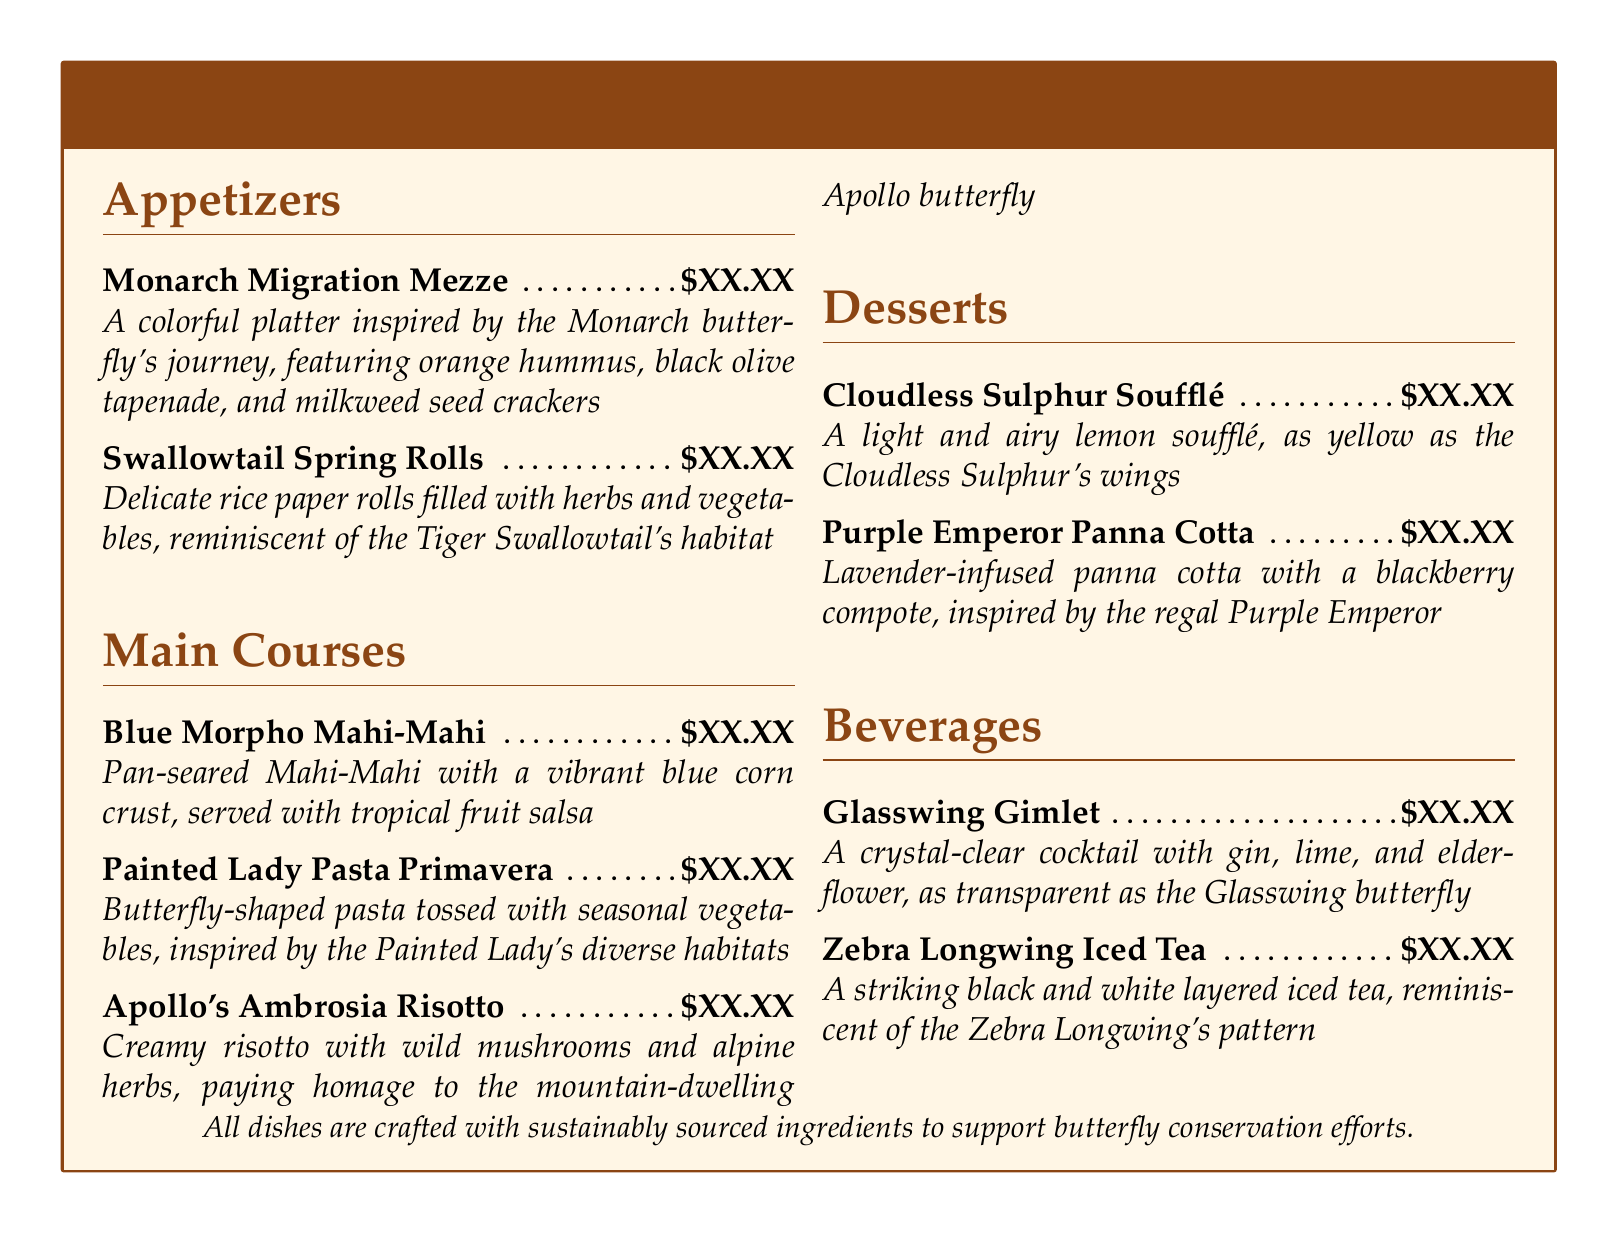What is the first appetizer listed? The first appetizer in the document is "Monarch Migration Mezze" as seen at the top of the appetizers section.
Answer: Monarch Migration Mezze How many main course options are there? The document lists three main course options under the Main Courses section.
Answer: 3 What is the key ingredient for the Cloudless Sulphur Soufflé? The Cloudless Sulphur Soufflé is described as a light and airy lemon soufflé, indicating that lemon is a key ingredient.
Answer: Lemon Which dessert is inspired by the Purple Emperor butterfly? The dessert inspired by the Purple Emperor butterfly is the "Purple Emperor Panna Cotta" as specified in the Desserts section.
Answer: Purple Emperor Panna Cotta What type of pasta is used in the Painted Lady Pasta Primavera? The Painted Lady Pasta Primavera features butterfly-shaped pasta, which is mentioned directly in the description.
Answer: Butterfly-shaped pasta What type of beverage is the Glasswing Gimlet? The Glasswing Gimlet is described as a crystal-clear cocktail, indicating it is a type of cocktail.
Answer: Cocktail What ingredient pairs well with the Apollo's Ambrosia Risotto? The Apollo's Ambrosia Risotto is described as having wild mushrooms and alpine herbs, suggesting these are key ingredients that pair well with it.
Answer: Wild mushrooms and alpine herbs How are the dishes sourced according to the menu? The menu states that "All dishes are crafted with sustainably sourced ingredients" to support conservation efforts.
Answer: Sustainably sourced ingredients 